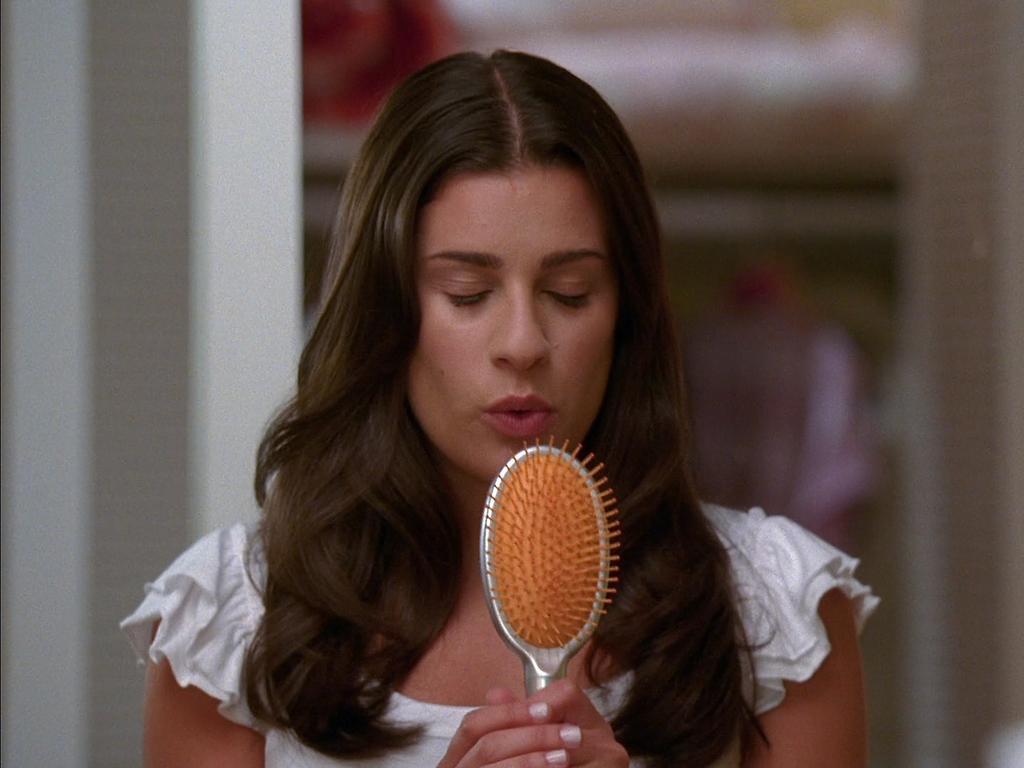In one or two sentences, can you explain what this image depicts? In this image there is a woman standing and holding a comb in her hand. The background is blurry. 